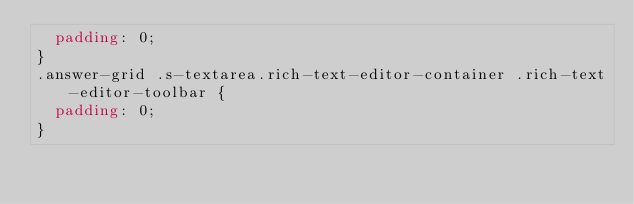<code> <loc_0><loc_0><loc_500><loc_500><_CSS_>  padding: 0;
}
.answer-grid .s-textarea.rich-text-editor-container .rich-text-editor-toolbar {
  padding: 0;
}
</code> 